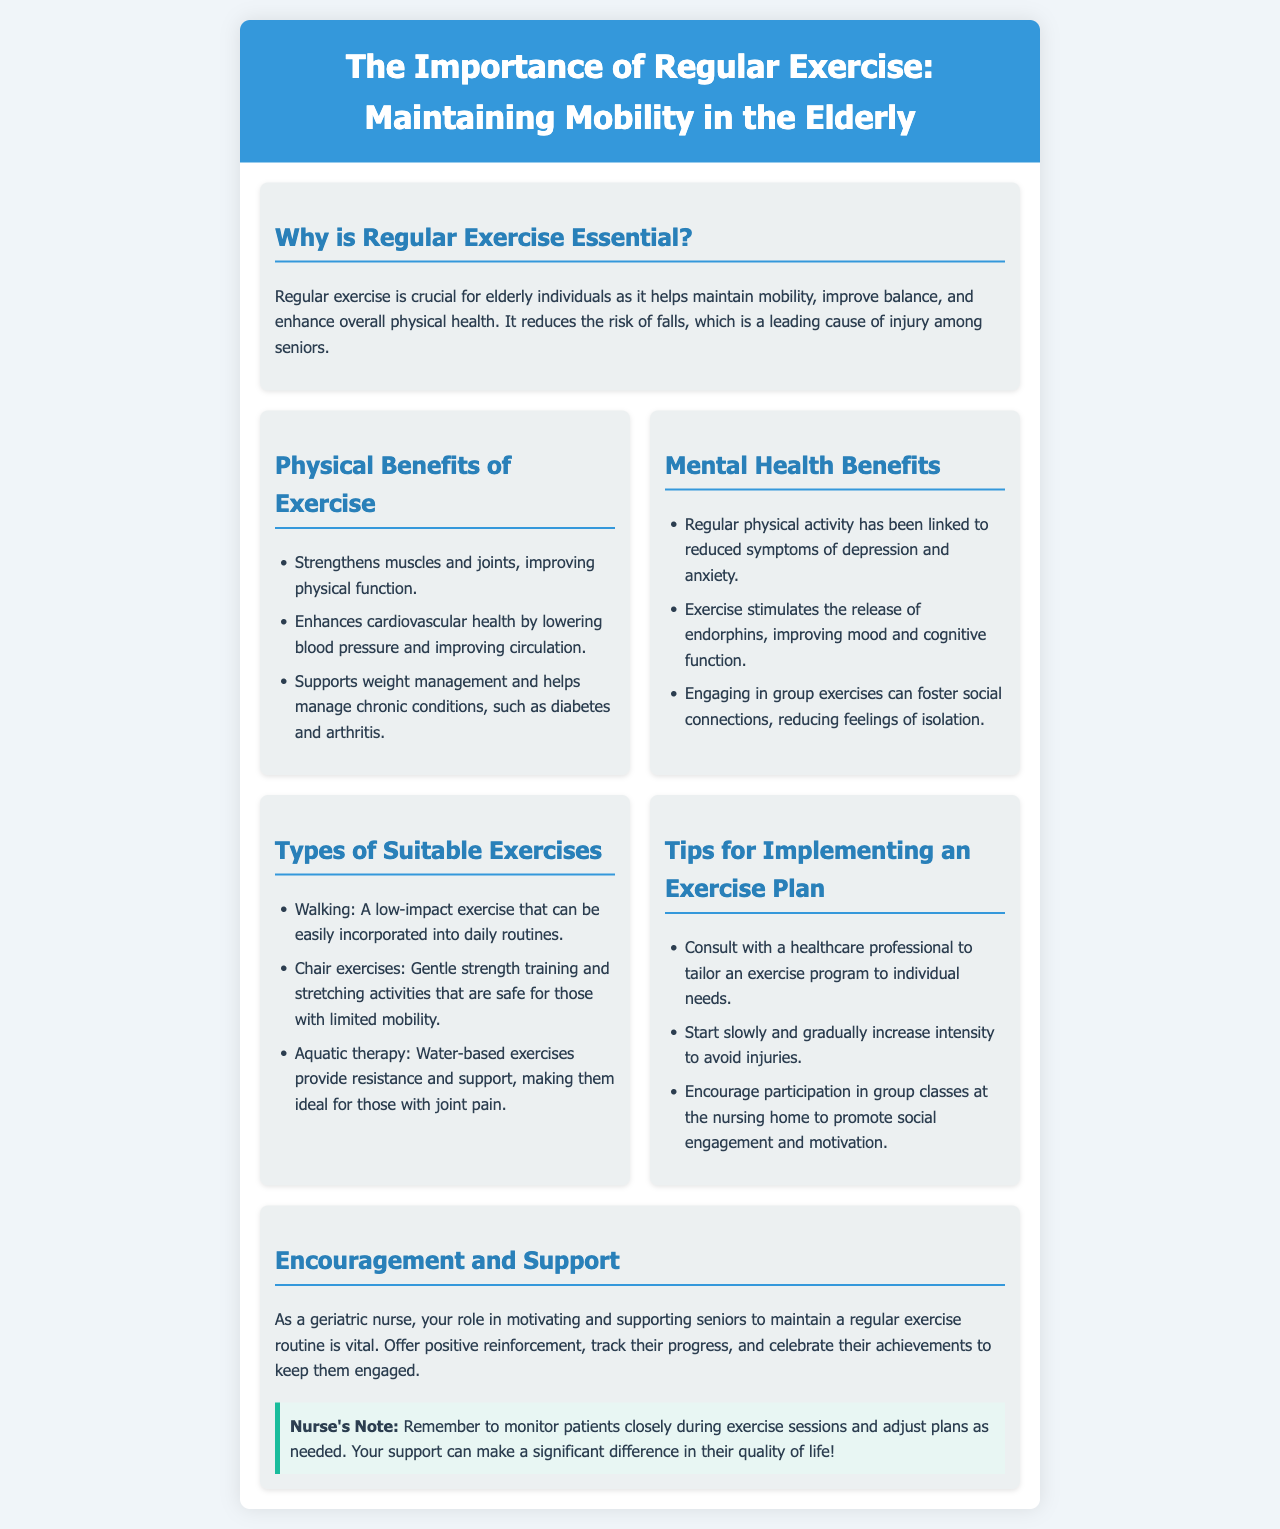What is the title of the brochure? The title is mentioned at the top of the document, emphasizing the subject matter related to exercise for the elderly.
Answer: The Importance of Regular Exercise: Maintaining Mobility in the Elderly Why is regular exercise essential? The document states that regular exercise helps maintain mobility, improve balance, and enhance overall physical health, particularly to reduce the risk of falls.
Answer: To maintain mobility, improve balance, and enhance overall physical health What is one physical benefit of exercise listed? The document provides a list of physical benefits, asking for one specific example from that list.
Answer: Strengthens muscles and joints, improving physical function What type of exercise is recommended for those with limited mobility? The document specifies exercises that are easy and safe for seniors, particularly those with limitations.
Answer: Chair exercises What should be considered when implementing an exercise plan? The document outlines various tips for creating an exercise plan, and the question seeks one consideration.
Answer: Consult with a healthcare professional How can exercise impact mental health? The text describes the relationship between regular physical activity and mental health outcomes, focusing on the benefits mentioned.
Answer: Reduces symptoms of depression and anxiety What specific encouragement should a nurse provide? The brochure highlights the role of a geriatric nurse in motivating seniors and offers supportive actions the nurse can take.
Answer: Offer positive reinforcement What is the primary role of a geriatric nurse in the context of exercise? The document discusses the importance of the nurse's support and motivation to help elderly patients maintain their exercise routines.
Answer: Motivating and supporting seniors What specific social benefit does group exercise provide? The brochure explains the advantages of exercising in groups, particularly in relation to mental and emotional well-being.
Answer: Fosters social connections, reducing feelings of isolation What is a key reminder for nurses during exercise sessions? The document emphasizes the importance of monitoring patients during exercise to ensure their safety and adjust plans as necessary.
Answer: Monitor patients closely during exercise sessions 